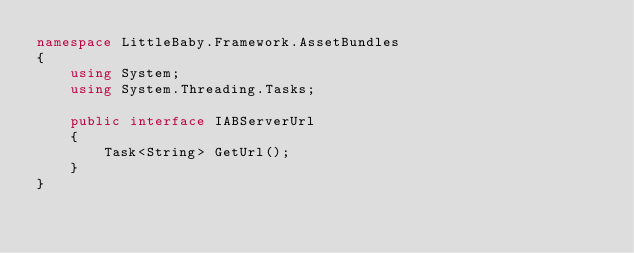<code> <loc_0><loc_0><loc_500><loc_500><_C#_>namespace LittleBaby.Framework.AssetBundles
{
    using System;
    using System.Threading.Tasks;

    public interface IABServerUrl
    {
        Task<String> GetUrl();
    }
}
</code> 